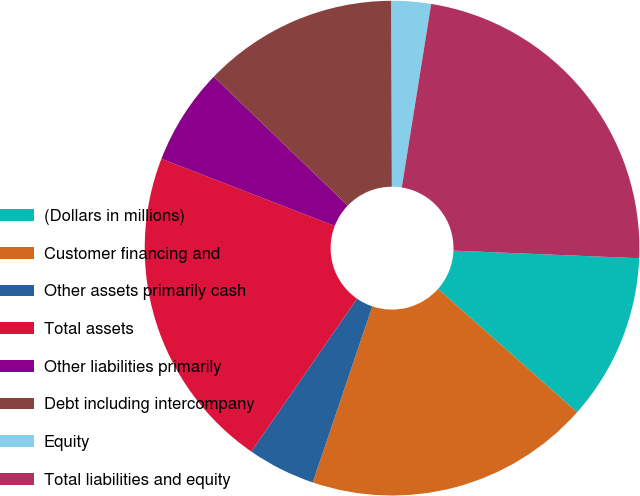Convert chart to OTSL. <chart><loc_0><loc_0><loc_500><loc_500><pie_chart><fcel>(Dollars in millions)<fcel>Customer financing and<fcel>Other assets primarily cash<fcel>Total assets<fcel>Other liabilities primarily<fcel>Debt including intercompany<fcel>Equity<fcel>Total liabilities and equity<nl><fcel>10.9%<fcel>18.65%<fcel>4.44%<fcel>21.25%<fcel>6.31%<fcel>12.77%<fcel>2.57%<fcel>23.12%<nl></chart> 